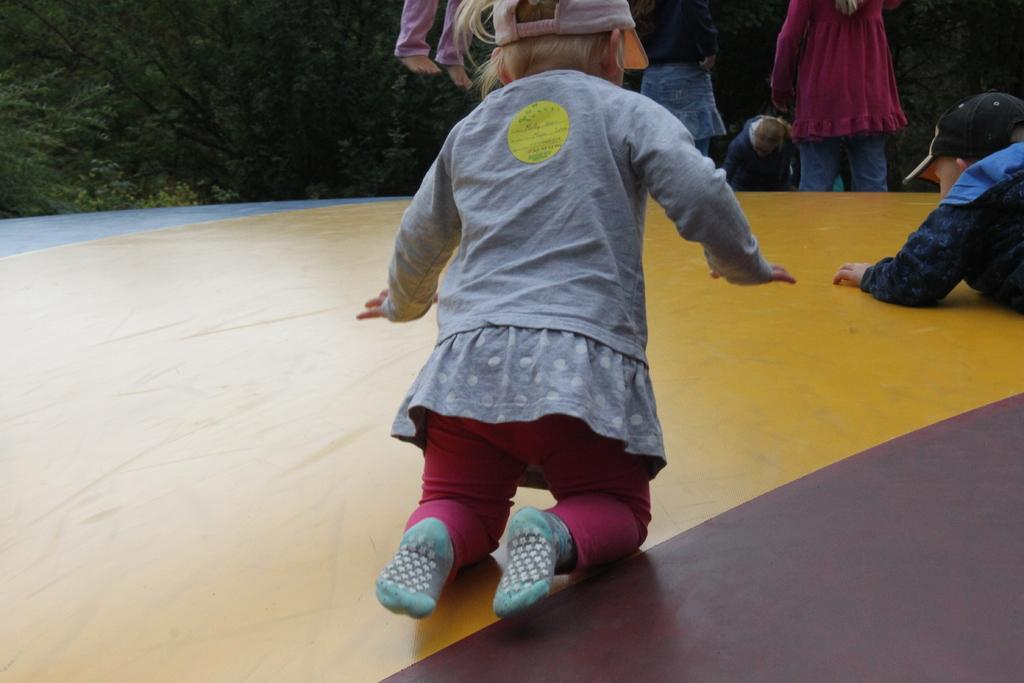What is the main subject in the center of the image? There is an object in the center of the image. What is happening on the object? Two kids are on the object. What are the kids wearing on their heads? The kids are wearing caps. What can be seen in the background of the image? There are trees and people in the background of the image. How many dolls are sitting on the banana in the image? There are no dolls or bananas present in the image. What type of spring is visible in the background of the image? There is no spring visible in the background of the image. 